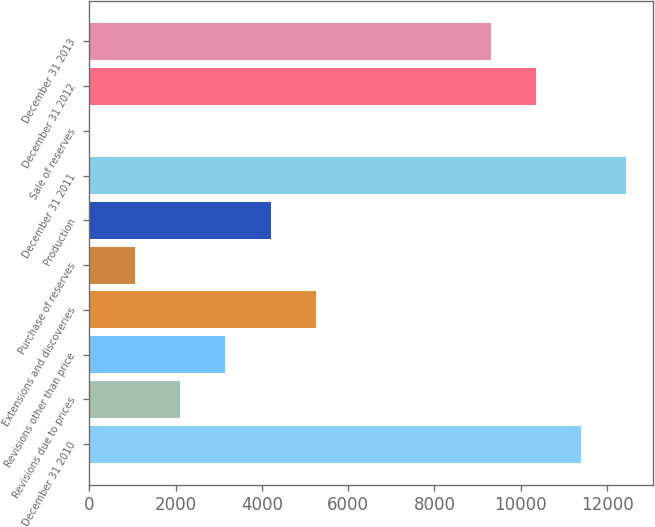<chart> <loc_0><loc_0><loc_500><loc_500><bar_chart><fcel>December 31 2010<fcel>Revisions due to prices<fcel>Revisions other than price<fcel>Extensions and discoveries<fcel>Purchase of reserves<fcel>Production<fcel>December 31 2011<fcel>Sale of reserves<fcel>December 31 2012<fcel>December 31 2013<nl><fcel>11402.8<fcel>2106.8<fcel>3154.2<fcel>5249<fcel>1059.4<fcel>4201.6<fcel>12450.2<fcel>12<fcel>10355.4<fcel>9308<nl></chart> 